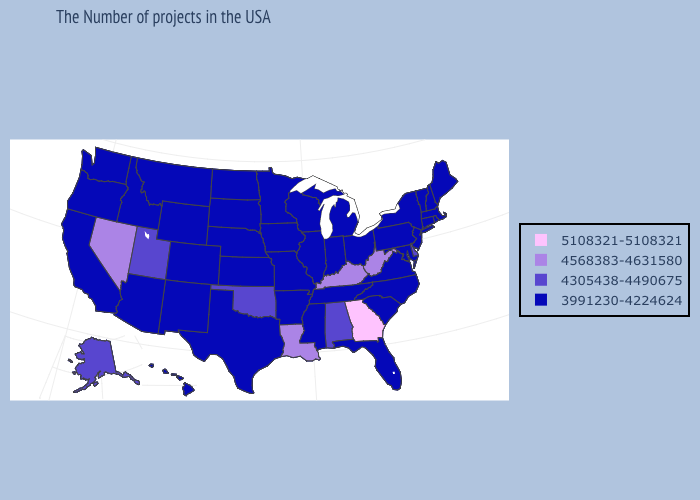Among the states that border Ohio , which have the highest value?
Write a very short answer. West Virginia, Kentucky. What is the lowest value in the USA?
Answer briefly. 3991230-4224624. Does Nevada have a lower value than Georgia?
Give a very brief answer. Yes. Does Georgia have the highest value in the South?
Answer briefly. Yes. How many symbols are there in the legend?
Answer briefly. 4. Name the states that have a value in the range 3991230-4224624?
Short answer required. Maine, Massachusetts, Rhode Island, New Hampshire, Vermont, Connecticut, New York, New Jersey, Maryland, Pennsylvania, Virginia, North Carolina, South Carolina, Ohio, Florida, Michigan, Indiana, Tennessee, Wisconsin, Illinois, Mississippi, Missouri, Arkansas, Minnesota, Iowa, Kansas, Nebraska, Texas, South Dakota, North Dakota, Wyoming, Colorado, New Mexico, Montana, Arizona, Idaho, California, Washington, Oregon, Hawaii. Does the map have missing data?
Short answer required. No. What is the highest value in the West ?
Short answer required. 4568383-4631580. What is the value of Florida?
Short answer required. 3991230-4224624. What is the lowest value in states that border North Carolina?
Answer briefly. 3991230-4224624. Does Pennsylvania have the same value as Nevada?
Short answer required. No. What is the highest value in the Northeast ?
Give a very brief answer. 3991230-4224624. Which states have the lowest value in the USA?
Quick response, please. Maine, Massachusetts, Rhode Island, New Hampshire, Vermont, Connecticut, New York, New Jersey, Maryland, Pennsylvania, Virginia, North Carolina, South Carolina, Ohio, Florida, Michigan, Indiana, Tennessee, Wisconsin, Illinois, Mississippi, Missouri, Arkansas, Minnesota, Iowa, Kansas, Nebraska, Texas, South Dakota, North Dakota, Wyoming, Colorado, New Mexico, Montana, Arizona, Idaho, California, Washington, Oregon, Hawaii. 